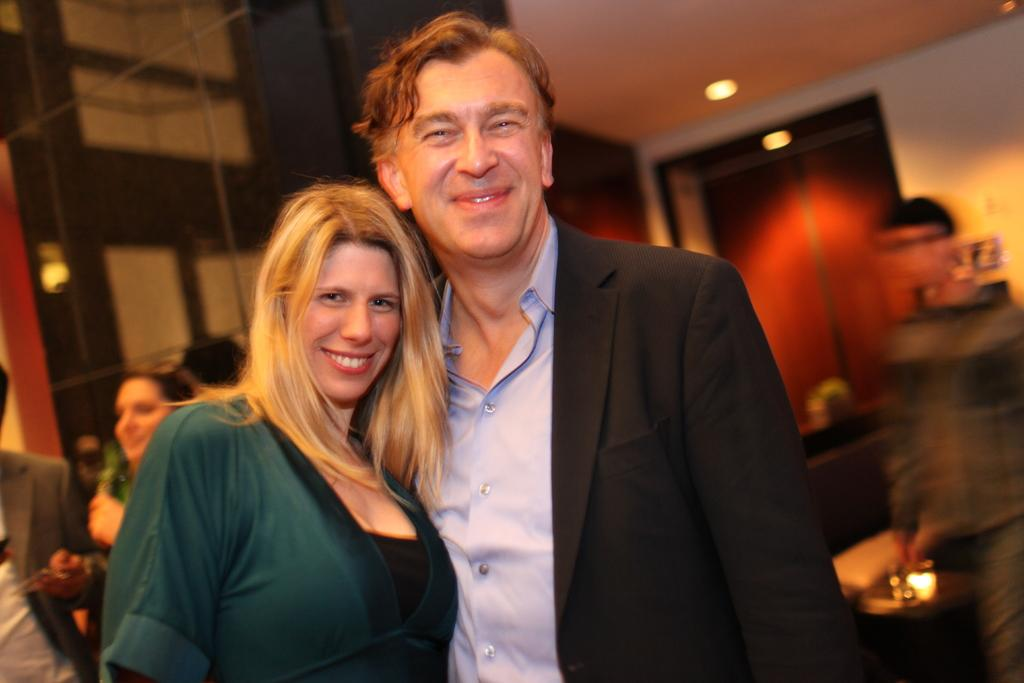How many people are in the image? There are two people in the image, a woman and a man. What are the woman and the man doing in the image? They are standing and posing for a photo. Can you describe the background of the image? The background of the image is blurred, and there are other people visible. What type of marble can be seen in the library in the image? There is no library or marble present in the image. What scientific discovery is being made by the people in the image? There is no indication of a scientific discovery being made in the image. 